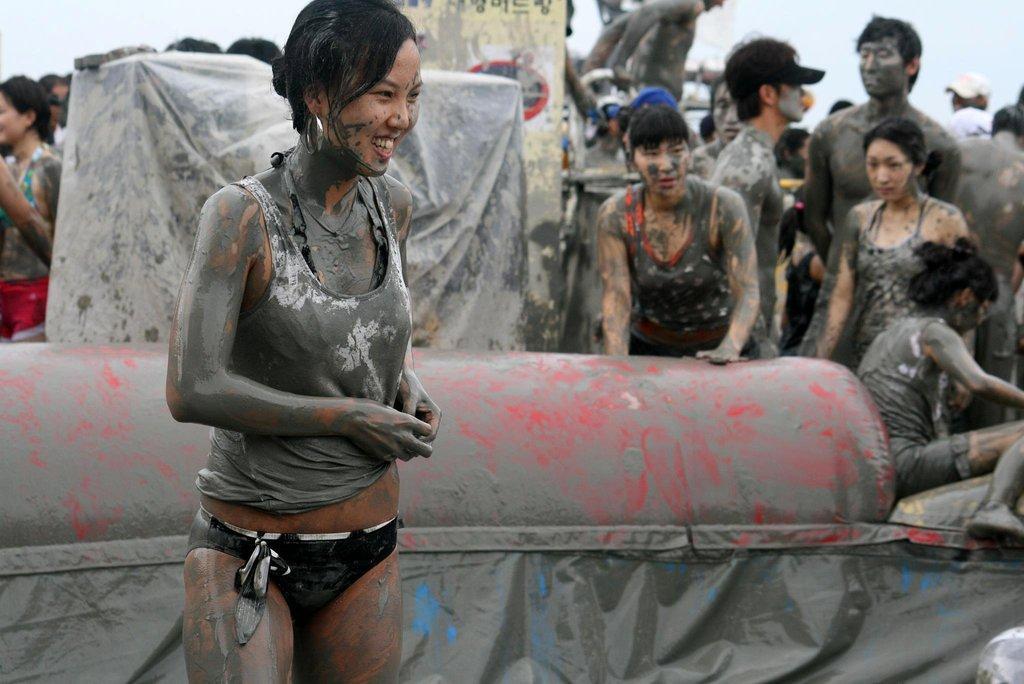Please provide a concise description of this image. In the image there is a woman in sweatshirt with mud all over her and in the back there are many people standing with mud all over them. 